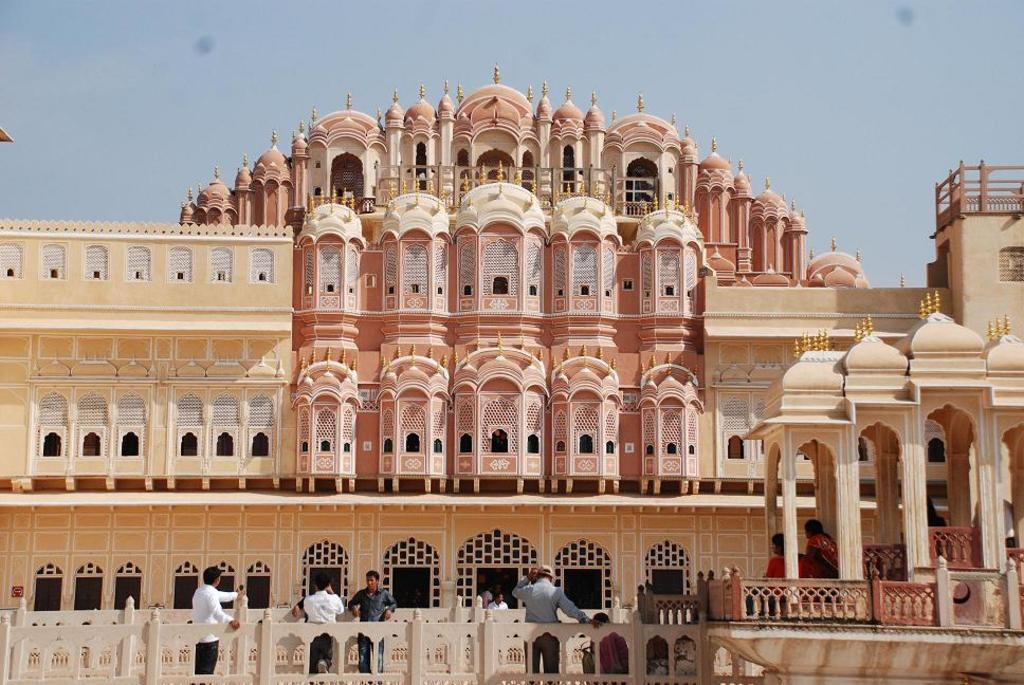How would you summarize this image in a sentence or two? This is an outside view. Here I can see the building. In front of this building there are few people standing and few are sitting. On the top of the image I can see the sky. 